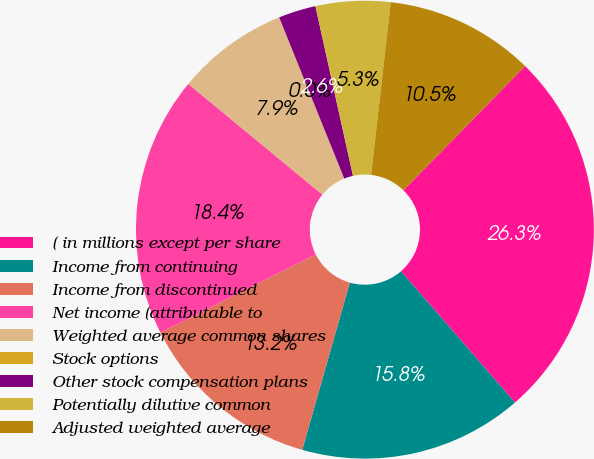<chart> <loc_0><loc_0><loc_500><loc_500><pie_chart><fcel>( in millions except per share<fcel>Income from continuing<fcel>Income from discontinued<fcel>Net income (attributable to<fcel>Weighted average common shares<fcel>Stock options<fcel>Other stock compensation plans<fcel>Potentially dilutive common<fcel>Adjusted weighted average<nl><fcel>26.3%<fcel>15.79%<fcel>13.16%<fcel>18.41%<fcel>7.9%<fcel>0.01%<fcel>2.64%<fcel>5.27%<fcel>10.53%<nl></chart> 